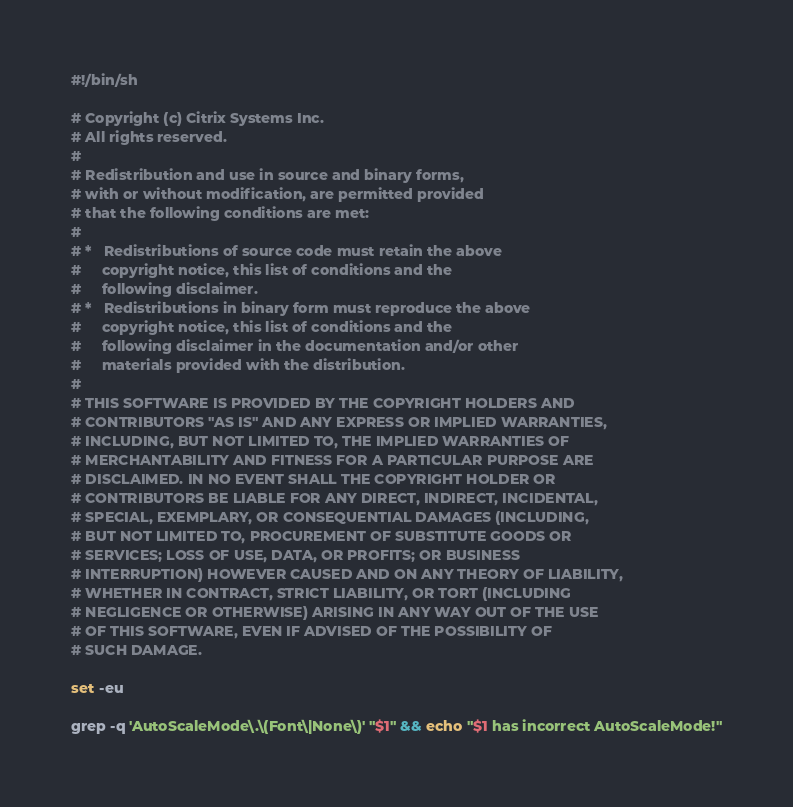Convert code to text. <code><loc_0><loc_0><loc_500><loc_500><_Bash_>#!/bin/sh

# Copyright (c) Citrix Systems Inc. 
# All rights reserved.
# 
# Redistribution and use in source and binary forms, 
# with or without modification, are permitted provided 
# that the following conditions are met: 
# 
# *   Redistributions of source code must retain the above 
#     copyright notice, this list of conditions and the 
#     following disclaimer. 
# *   Redistributions in binary form must reproduce the above 
#     copyright notice, this list of conditions and the 
#     following disclaimer in the documentation and/or other 
#     materials provided with the distribution. 
# 
# THIS SOFTWARE IS PROVIDED BY THE COPYRIGHT HOLDERS AND 
# CONTRIBUTORS "AS IS" AND ANY EXPRESS OR IMPLIED WARRANTIES, 
# INCLUDING, BUT NOT LIMITED TO, THE IMPLIED WARRANTIES OF 
# MERCHANTABILITY AND FITNESS FOR A PARTICULAR PURPOSE ARE 
# DISCLAIMED. IN NO EVENT SHALL THE COPYRIGHT HOLDER OR 
# CONTRIBUTORS BE LIABLE FOR ANY DIRECT, INDIRECT, INCIDENTAL, 
# SPECIAL, EXEMPLARY, OR CONSEQUENTIAL DAMAGES (INCLUDING, 
# BUT NOT LIMITED TO, PROCUREMENT OF SUBSTITUTE GOODS OR 
# SERVICES; LOSS OF USE, DATA, OR PROFITS; OR BUSINESS 
# INTERRUPTION) HOWEVER CAUSED AND ON ANY THEORY OF LIABILITY, 
# WHETHER IN CONTRACT, STRICT LIABILITY, OR TORT (INCLUDING 
# NEGLIGENCE OR OTHERWISE) ARISING IN ANY WAY OUT OF THE USE 
# OF THIS SOFTWARE, EVEN IF ADVISED OF THE POSSIBILITY OF 
# SUCH DAMAGE.

set -eu

grep -q 'AutoScaleMode\.\(Font\|None\)' "$1" && echo "$1 has incorrect AutoScaleMode!"
</code> 